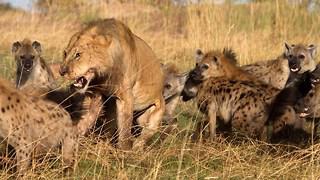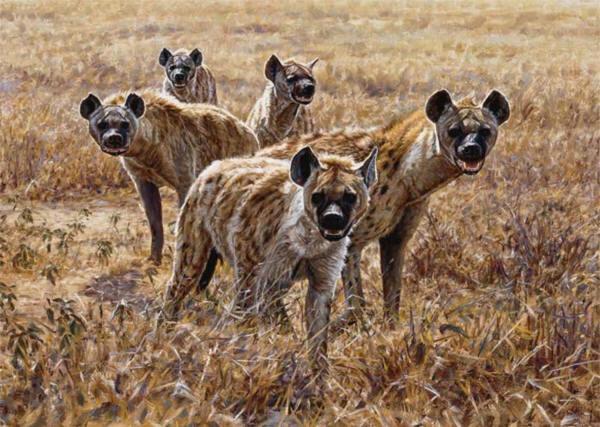The first image is the image on the left, the second image is the image on the right. Evaluate the accuracy of this statement regarding the images: "Multiple hyenas and one open-mouthed lion are engaged in action in one image.". Is it true? Answer yes or no. Yes. The first image is the image on the left, the second image is the image on the right. Considering the images on both sides, is "Hyenas are attacking a lion." valid? Answer yes or no. Yes. 